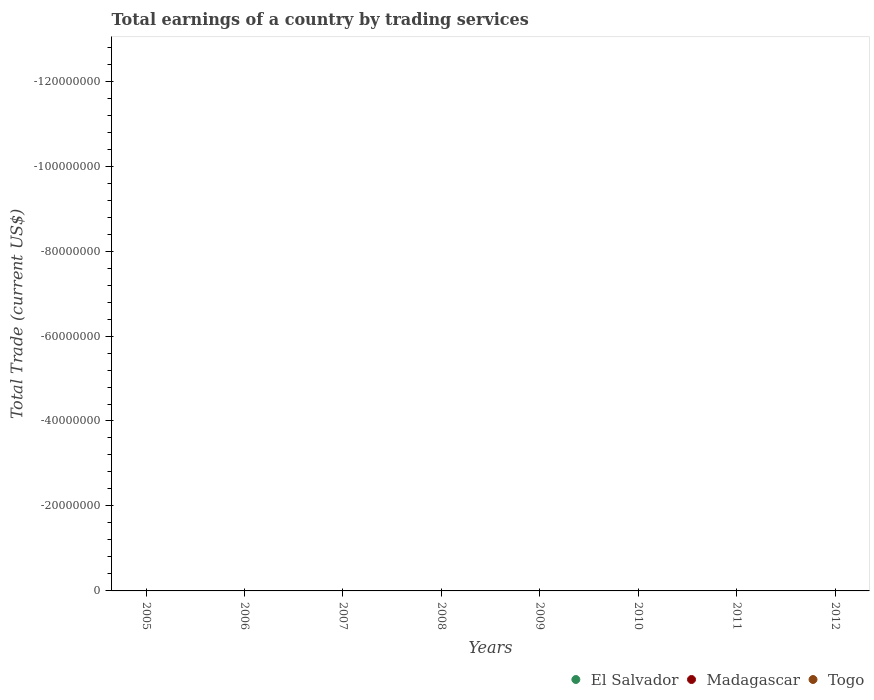Is the number of dotlines equal to the number of legend labels?
Give a very brief answer. No. What is the total earnings in El Salvador in 2007?
Keep it short and to the point. 0. In how many years, is the total earnings in Togo greater than -64000000 US$?
Your answer should be compact. 0. Does the total earnings in El Salvador monotonically increase over the years?
Give a very brief answer. No. How many years are there in the graph?
Give a very brief answer. 8. How many legend labels are there?
Offer a terse response. 3. What is the title of the graph?
Ensure brevity in your answer.  Total earnings of a country by trading services. Does "Djibouti" appear as one of the legend labels in the graph?
Give a very brief answer. No. What is the label or title of the Y-axis?
Your response must be concise. Total Trade (current US$). What is the Total Trade (current US$) in El Salvador in 2006?
Provide a succinct answer. 0. What is the Total Trade (current US$) of Madagascar in 2006?
Ensure brevity in your answer.  0. What is the Total Trade (current US$) of Madagascar in 2007?
Your response must be concise. 0. What is the Total Trade (current US$) of El Salvador in 2008?
Provide a short and direct response. 0. What is the Total Trade (current US$) in Togo in 2008?
Provide a short and direct response. 0. What is the Total Trade (current US$) of El Salvador in 2009?
Give a very brief answer. 0. What is the Total Trade (current US$) of Togo in 2009?
Make the answer very short. 0. What is the Total Trade (current US$) of El Salvador in 2010?
Provide a succinct answer. 0. What is the Total Trade (current US$) of Madagascar in 2010?
Provide a short and direct response. 0. What is the Total Trade (current US$) in Togo in 2010?
Your answer should be compact. 0. What is the Total Trade (current US$) in El Salvador in 2011?
Provide a succinct answer. 0. What is the Total Trade (current US$) in Togo in 2011?
Offer a very short reply. 0. What is the Total Trade (current US$) in El Salvador in 2012?
Ensure brevity in your answer.  0. What is the Total Trade (current US$) in Madagascar in 2012?
Make the answer very short. 0. What is the Total Trade (current US$) of Togo in 2012?
Provide a succinct answer. 0. What is the total Total Trade (current US$) in Togo in the graph?
Your answer should be very brief. 0. What is the average Total Trade (current US$) in Madagascar per year?
Provide a succinct answer. 0. 